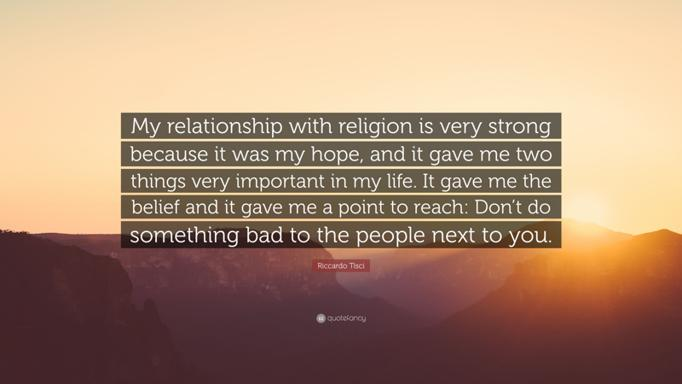What does the inclusion of a natural landscape signify in relation to the speaker's message? The natural landscape underscores a sense of vastness and calm, suggesting that just as the earth sustains life, the speaker's faith sustains their spirit and moral vision. 